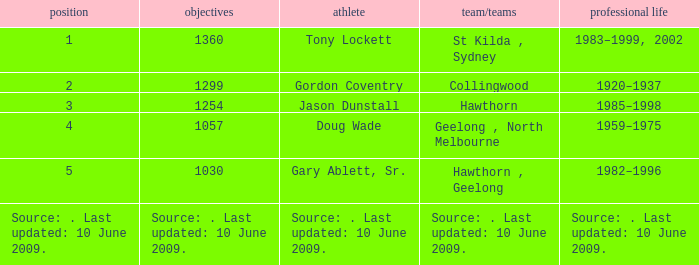Which player has 1299 goals? Gordon Coventry. 